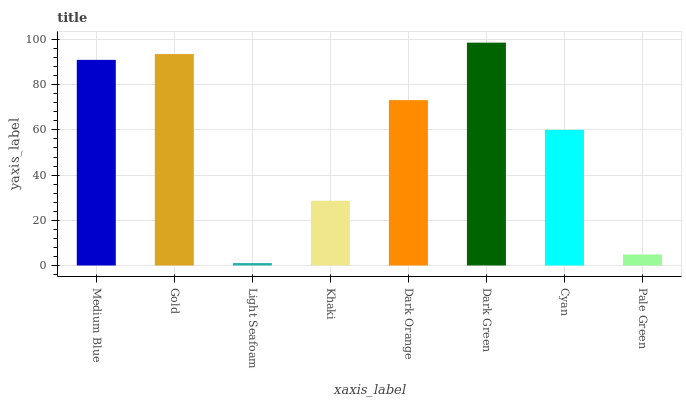Is Light Seafoam the minimum?
Answer yes or no. Yes. Is Dark Green the maximum?
Answer yes or no. Yes. Is Gold the minimum?
Answer yes or no. No. Is Gold the maximum?
Answer yes or no. No. Is Gold greater than Medium Blue?
Answer yes or no. Yes. Is Medium Blue less than Gold?
Answer yes or no. Yes. Is Medium Blue greater than Gold?
Answer yes or no. No. Is Gold less than Medium Blue?
Answer yes or no. No. Is Dark Orange the high median?
Answer yes or no. Yes. Is Cyan the low median?
Answer yes or no. Yes. Is Light Seafoam the high median?
Answer yes or no. No. Is Dark Orange the low median?
Answer yes or no. No. 